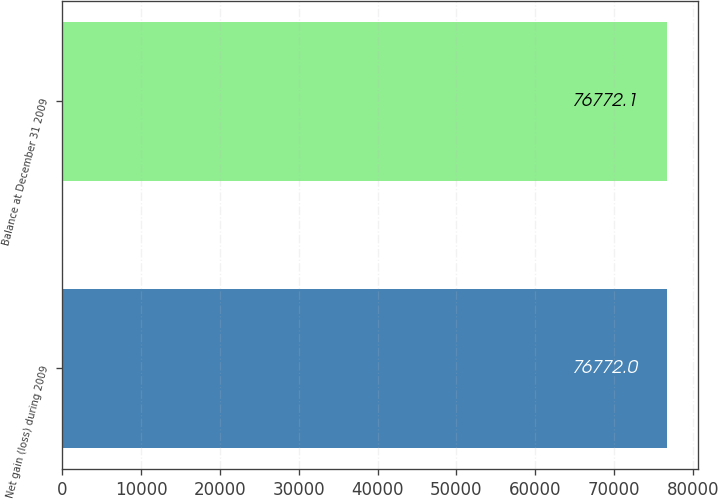Convert chart to OTSL. <chart><loc_0><loc_0><loc_500><loc_500><bar_chart><fcel>Net gain (loss) during 2009<fcel>Balance at December 31 2009<nl><fcel>76772<fcel>76772.1<nl></chart> 